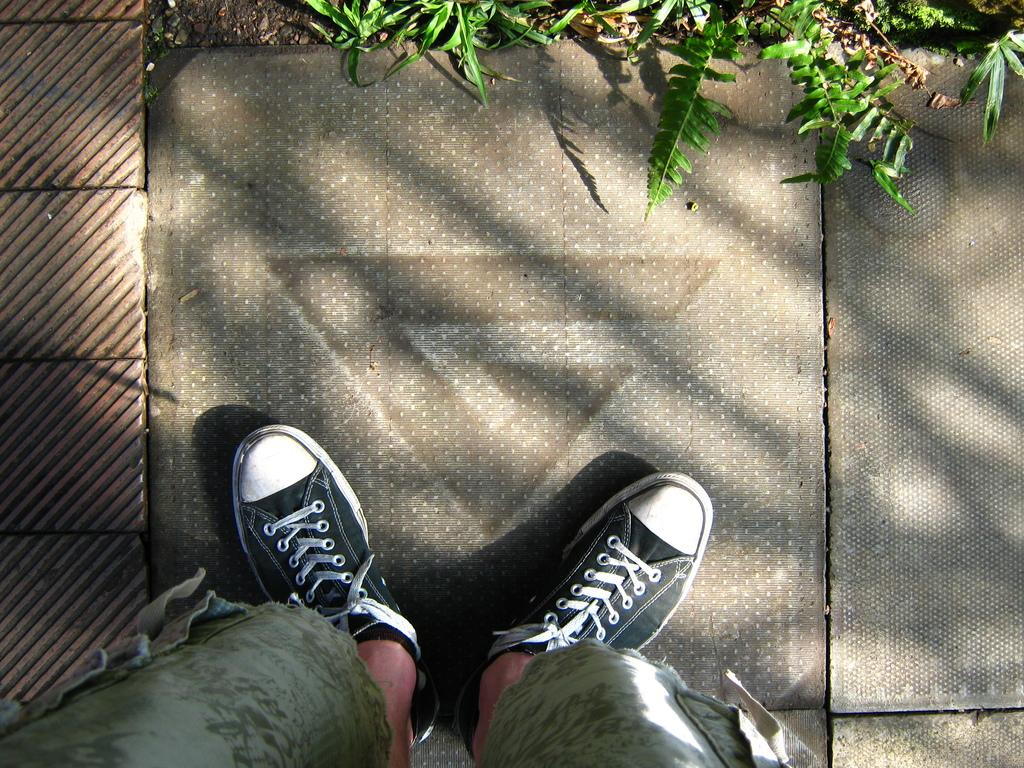What body part is visible in the image? There are a person's legs in the image. What type of footwear is the person wearing? The person is wearing shoes. Where are the legs and shoes located? The legs and shoes are on the ground. What type of vegetation can be seen in the background of the image? There is grass visible in the background of the image. What color is the orange that the person is holding in the image? There is no orange present in the image; only the person's legs and shoes are visible. 